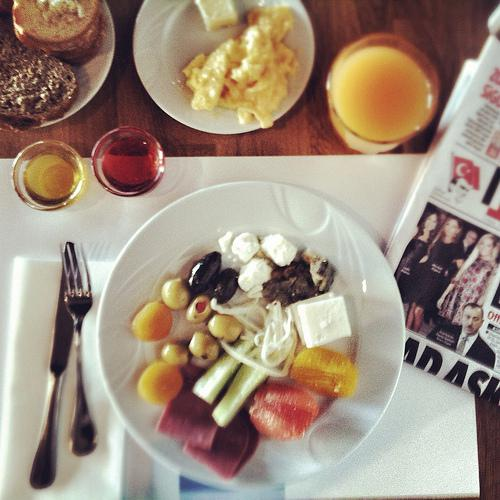Question: what color are the plates?
Choices:
A. Blue.
B. Yellow.
C. Green.
D. White.
Answer with the letter. Answer: D Question: when was the picture taken?
Choices:
A. Last night.
B. Twenty years go.
C. 1979.
D. Morning.
Answer with the letter. Answer: D Question: how many glasses are visible?
Choices:
A. Four.
B. Five.
C. Three.
D. Six.
Answer with the letter. Answer: C Question: what is on the napkin?
Choices:
A. A fly.
B. Sauce.
C. Silverware.
D. My hands.
Answer with the letter. Answer: C 